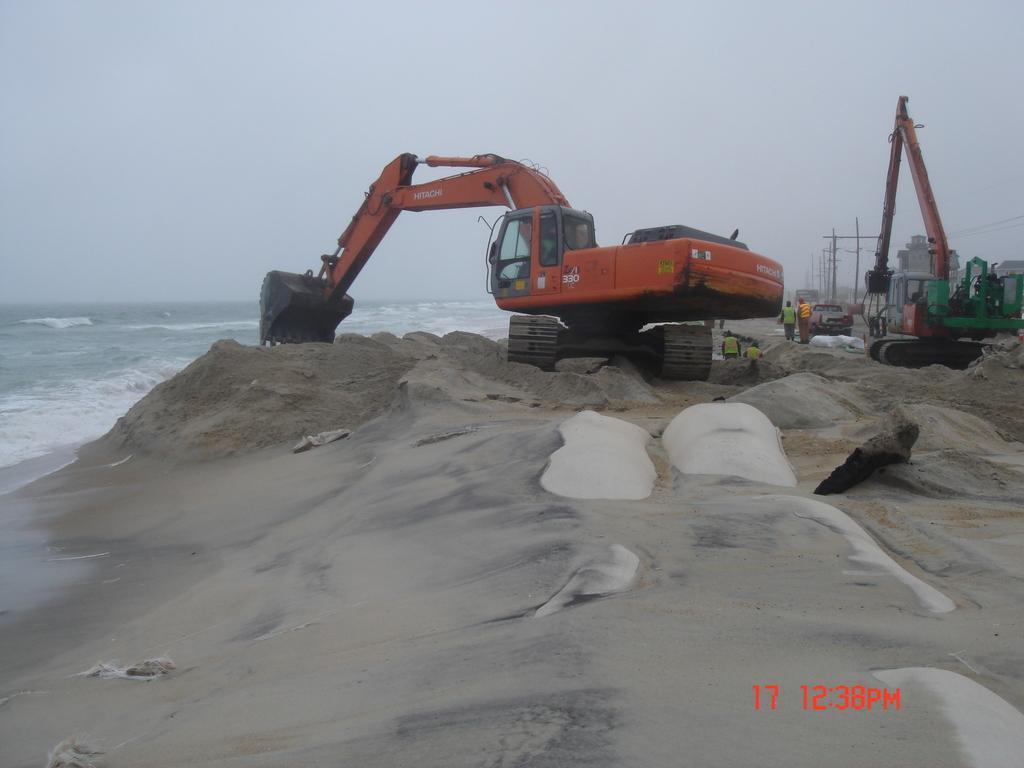Could you give a brief overview of what you see in this image? In this picture we can see there are two proclainer, people, poles and a vehicle. At the bottom of the image there is sand. On the left side of the image there is sea and the sky. On the image there is a watermark. 